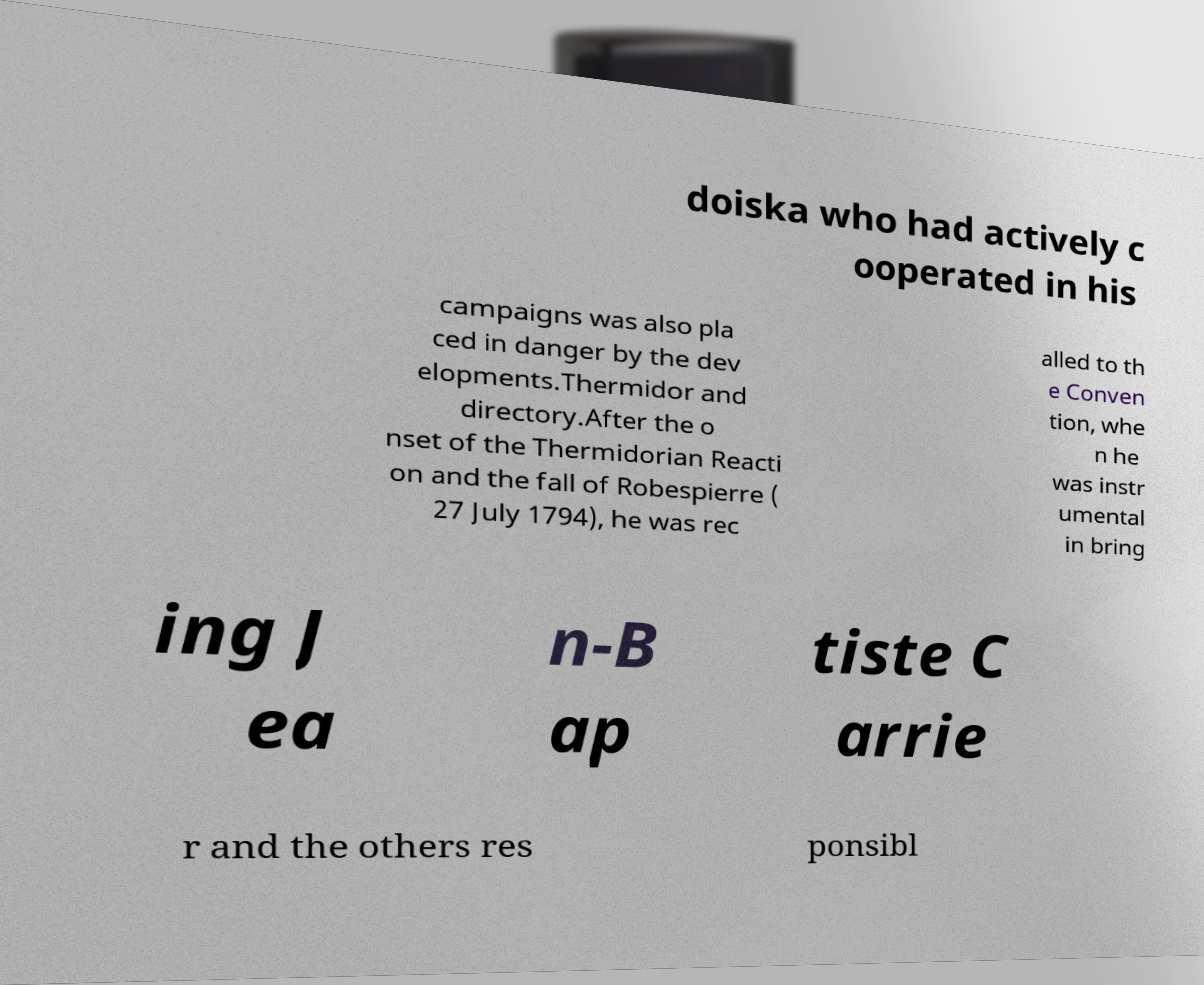Can you accurately transcribe the text from the provided image for me? doiska who had actively c ooperated in his campaigns was also pla ced in danger by the dev elopments.Thermidor and directory.After the o nset of the Thermidorian Reacti on and the fall of Robespierre ( 27 July 1794), he was rec alled to th e Conven tion, whe n he was instr umental in bring ing J ea n-B ap tiste C arrie r and the others res ponsibl 